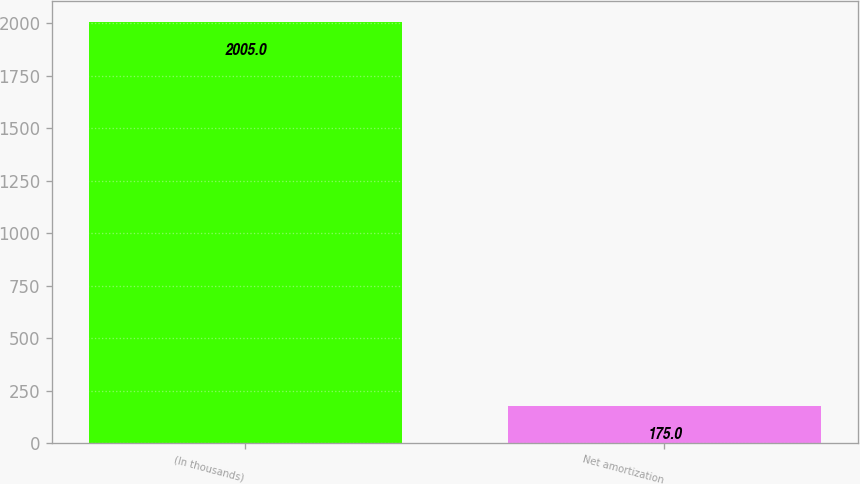Convert chart to OTSL. <chart><loc_0><loc_0><loc_500><loc_500><bar_chart><fcel>(In thousands)<fcel>Net amortization<nl><fcel>2005<fcel>175<nl></chart> 